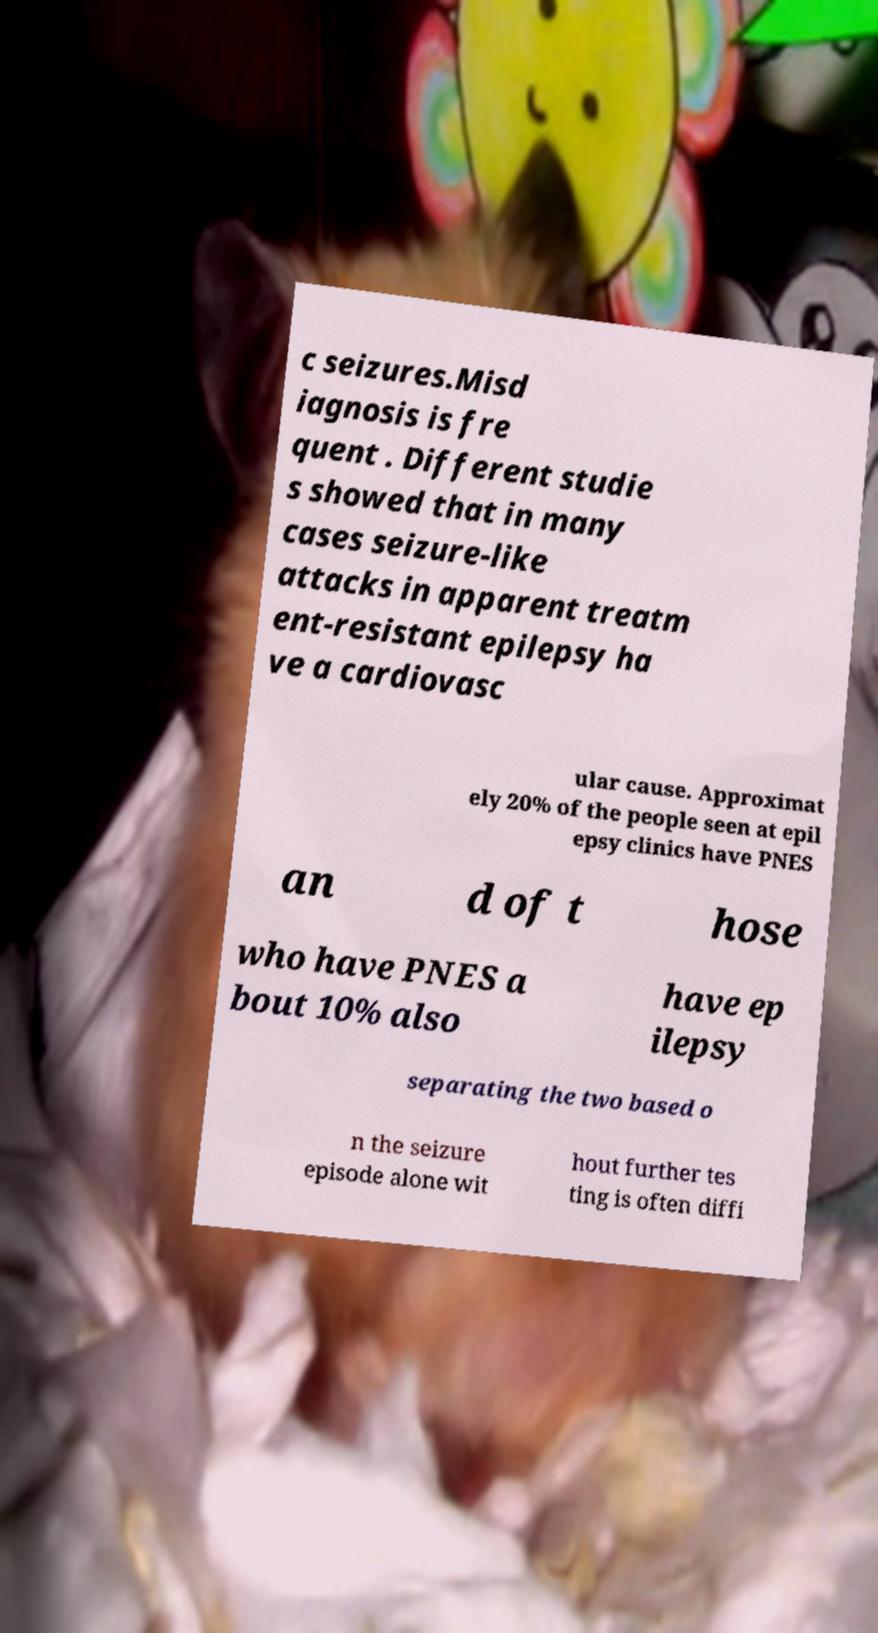Can you accurately transcribe the text from the provided image for me? c seizures.Misd iagnosis is fre quent . Different studie s showed that in many cases seizure-like attacks in apparent treatm ent-resistant epilepsy ha ve a cardiovasc ular cause. Approximat ely 20% of the people seen at epil epsy clinics have PNES an d of t hose who have PNES a bout 10% also have ep ilepsy separating the two based o n the seizure episode alone wit hout further tes ting is often diffi 